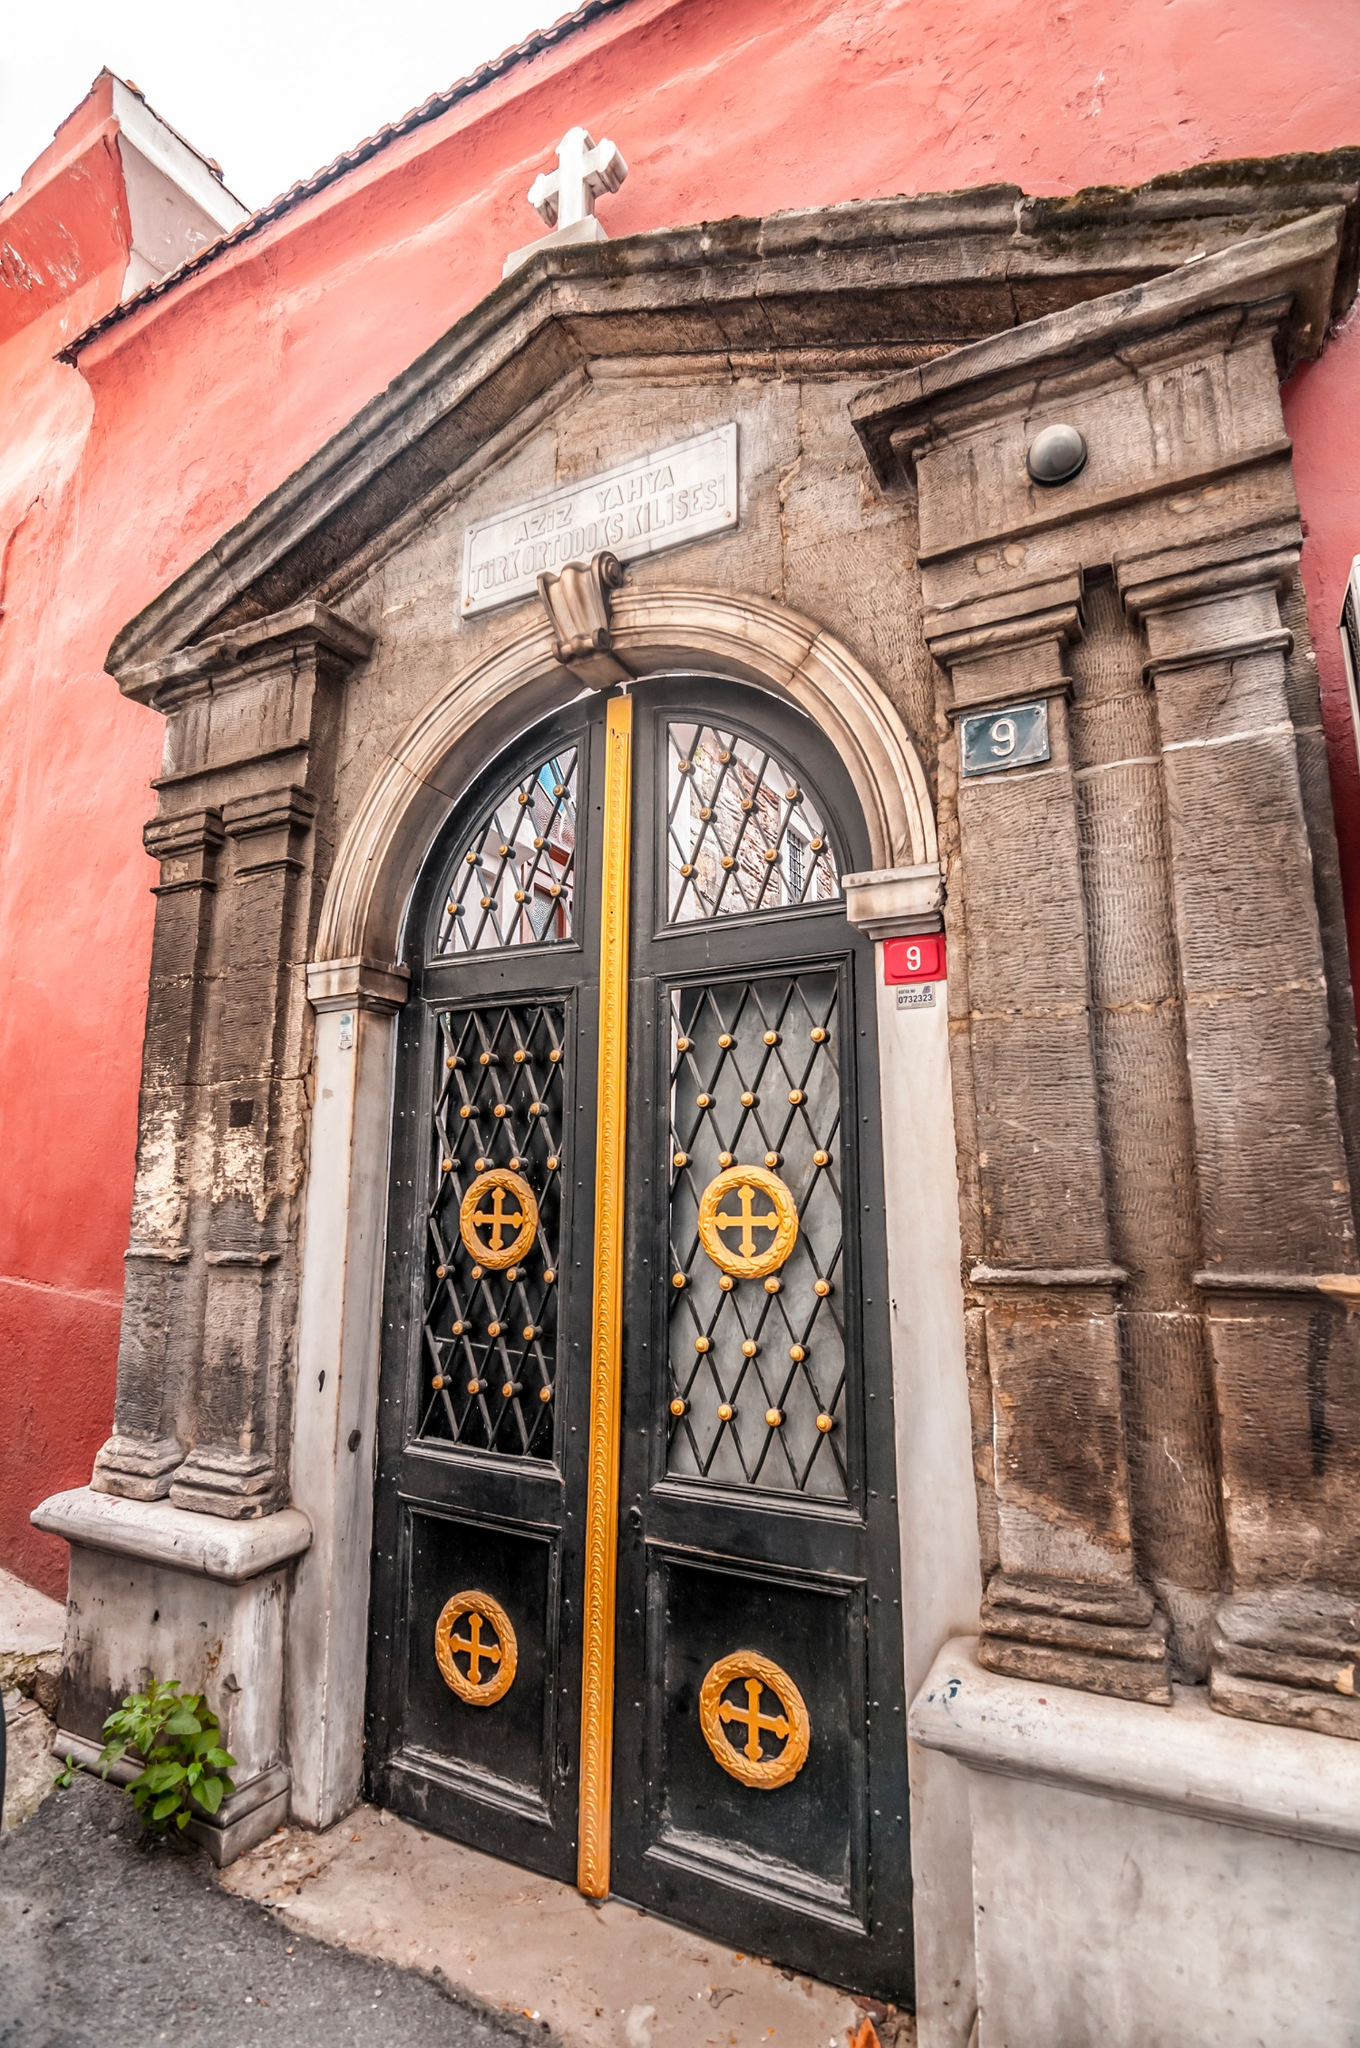What's happening in the scene? The image depicts a detailed and ornate entrance to a red building, which appears to be a historical or religious site. The focal point is the arched, black metal door adorned with gold crosses and a gold handle. The door is surrounded by two stone columns adding a sense of grandeur. Above the door, a plaque is inscribed with 'ΑΓΙΑ ΠΑΡΑΣΚΕΥΗ' suggesting a Greek Orthodox church. A small plant to the left of the door adds a touch of green. The architectural style and detailing suggest this building may have significant cultural or religious importance. 